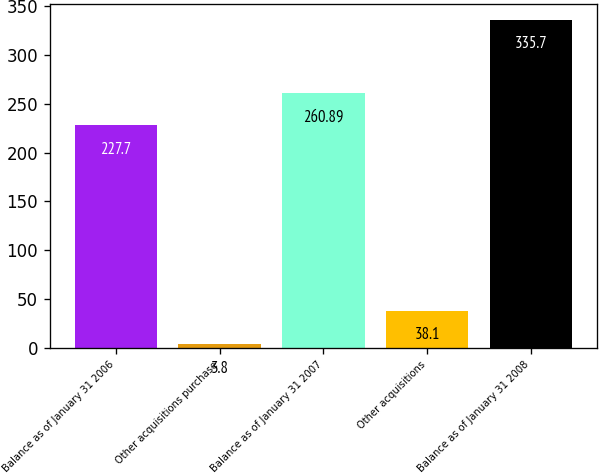Convert chart. <chart><loc_0><loc_0><loc_500><loc_500><bar_chart><fcel>Balance as of January 31 2006<fcel>Other acquisitions purchase<fcel>Balance as of January 31 2007<fcel>Other acquisitions<fcel>Balance as of January 31 2008<nl><fcel>227.7<fcel>3.8<fcel>260.89<fcel>38.1<fcel>335.7<nl></chart> 